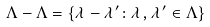<formula> <loc_0><loc_0><loc_500><loc_500>\Lambda - \Lambda = \left \{ \lambda - \lambda ^ { \prime } \colon \lambda , \lambda ^ { \prime } \in \Lambda \right \}</formula> 